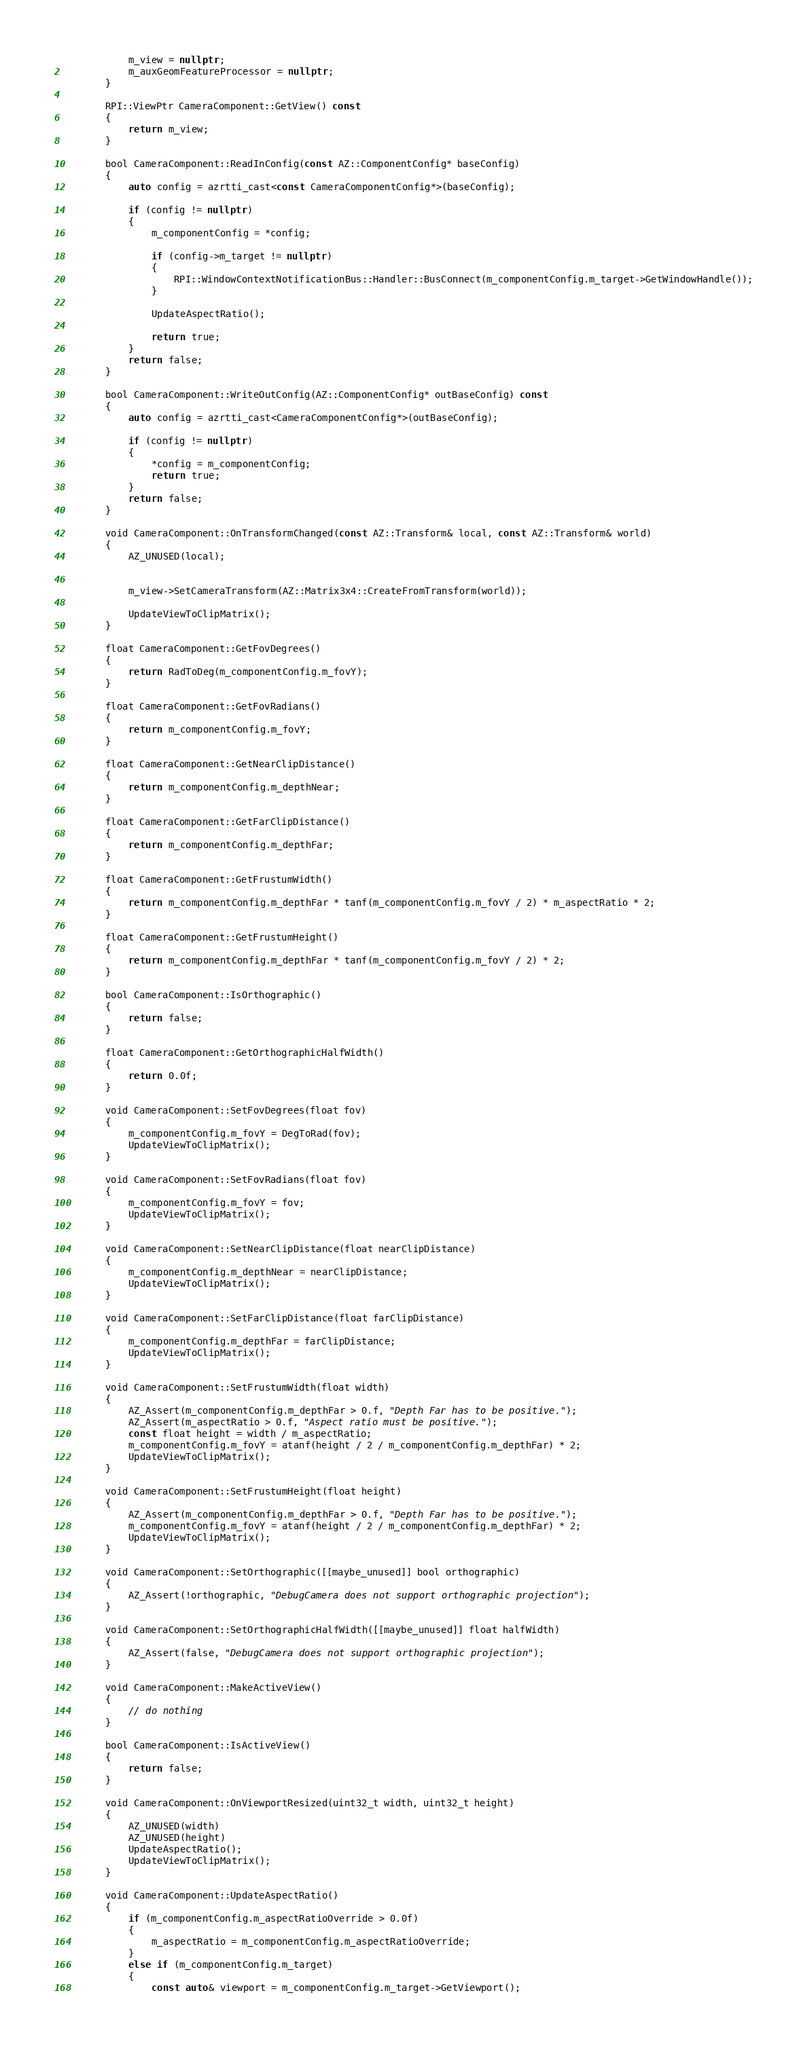Convert code to text. <code><loc_0><loc_0><loc_500><loc_500><_C++_>            m_view = nullptr;
            m_auxGeomFeatureProcessor = nullptr;
        }

        RPI::ViewPtr CameraComponent::GetView() const
        {
            return m_view;
        }

        bool CameraComponent::ReadInConfig(const AZ::ComponentConfig* baseConfig)
        {
            auto config = azrtti_cast<const CameraComponentConfig*>(baseConfig);

            if (config != nullptr)
            {
                m_componentConfig = *config;

                if (config->m_target != nullptr)
                {
                    RPI::WindowContextNotificationBus::Handler::BusConnect(m_componentConfig.m_target->GetWindowHandle());
                }

                UpdateAspectRatio();

                return true;
            }
            return false;
        }

        bool CameraComponent::WriteOutConfig(AZ::ComponentConfig* outBaseConfig) const
        {
            auto config = azrtti_cast<CameraComponentConfig*>(outBaseConfig);

            if (config != nullptr)
            {
                *config = m_componentConfig;
                return true;
            }
            return false;
        }

        void CameraComponent::OnTransformChanged(const AZ::Transform& local, const AZ::Transform& world)
        {
            AZ_UNUSED(local);


            m_view->SetCameraTransform(AZ::Matrix3x4::CreateFromTransform(world));

            UpdateViewToClipMatrix();
        }

        float CameraComponent::GetFovDegrees()
        {
            return RadToDeg(m_componentConfig.m_fovY);
        }

        float CameraComponent::GetFovRadians()
        {
            return m_componentConfig.m_fovY;
        }

        float CameraComponent::GetNearClipDistance() 
        {
            return m_componentConfig.m_depthNear;
        }

        float CameraComponent::GetFarClipDistance()
        {
            return m_componentConfig.m_depthFar;
        }

        float CameraComponent::GetFrustumWidth()
        {
            return m_componentConfig.m_depthFar * tanf(m_componentConfig.m_fovY / 2) * m_aspectRatio * 2;
        }

        float CameraComponent::GetFrustumHeight()
        {
            return m_componentConfig.m_depthFar * tanf(m_componentConfig.m_fovY / 2) * 2;
        }

        bool CameraComponent::IsOrthographic()
        {
            return false;
        }

        float CameraComponent::GetOrthographicHalfWidth()
        {
            return 0.0f;
        }

        void CameraComponent::SetFovDegrees(float fov)
        {
            m_componentConfig.m_fovY = DegToRad(fov);
            UpdateViewToClipMatrix();
        }

        void CameraComponent::SetFovRadians(float fov)
        {
            m_componentConfig.m_fovY = fov;
            UpdateViewToClipMatrix();
        }

        void CameraComponent::SetNearClipDistance(float nearClipDistance)
        {
            m_componentConfig.m_depthNear = nearClipDistance;
            UpdateViewToClipMatrix();
        }

        void CameraComponent::SetFarClipDistance(float farClipDistance) 
        {
            m_componentConfig.m_depthFar = farClipDistance;
            UpdateViewToClipMatrix();
        }

        void CameraComponent::SetFrustumWidth(float width)
        {
            AZ_Assert(m_componentConfig.m_depthFar > 0.f, "Depth Far has to be positive.");
            AZ_Assert(m_aspectRatio > 0.f, "Aspect ratio must be positive.");
            const float height = width / m_aspectRatio;
            m_componentConfig.m_fovY = atanf(height / 2 / m_componentConfig.m_depthFar) * 2;
            UpdateViewToClipMatrix();
        }

        void CameraComponent::SetFrustumHeight(float height)
        {
            AZ_Assert(m_componentConfig.m_depthFar > 0.f, "Depth Far has to be positive.");
            m_componentConfig.m_fovY = atanf(height / 2 / m_componentConfig.m_depthFar) * 2;
            UpdateViewToClipMatrix();
        }

        void CameraComponent::SetOrthographic([[maybe_unused]] bool orthographic)
        {
            AZ_Assert(!orthographic, "DebugCamera does not support orthographic projection");
        }

        void CameraComponent::SetOrthographicHalfWidth([[maybe_unused]] float halfWidth)
        {
            AZ_Assert(false, "DebugCamera does not support orthographic projection");
        }

        void CameraComponent::MakeActiveView() 
        {
            // do nothing
        }

        bool CameraComponent::IsActiveView()
        {
            return false;
        }

        void CameraComponent::OnViewportResized(uint32_t width, uint32_t height)
        {
            AZ_UNUSED(width)
            AZ_UNUSED(height)
            UpdateAspectRatio();
            UpdateViewToClipMatrix();
        }

        void CameraComponent::UpdateAspectRatio()
        {
            if (m_componentConfig.m_aspectRatioOverride > 0.0f)
            {
                m_aspectRatio = m_componentConfig.m_aspectRatioOverride;
            }
            else if (m_componentConfig.m_target)
            {
                const auto& viewport = m_componentConfig.m_target->GetViewport();</code> 